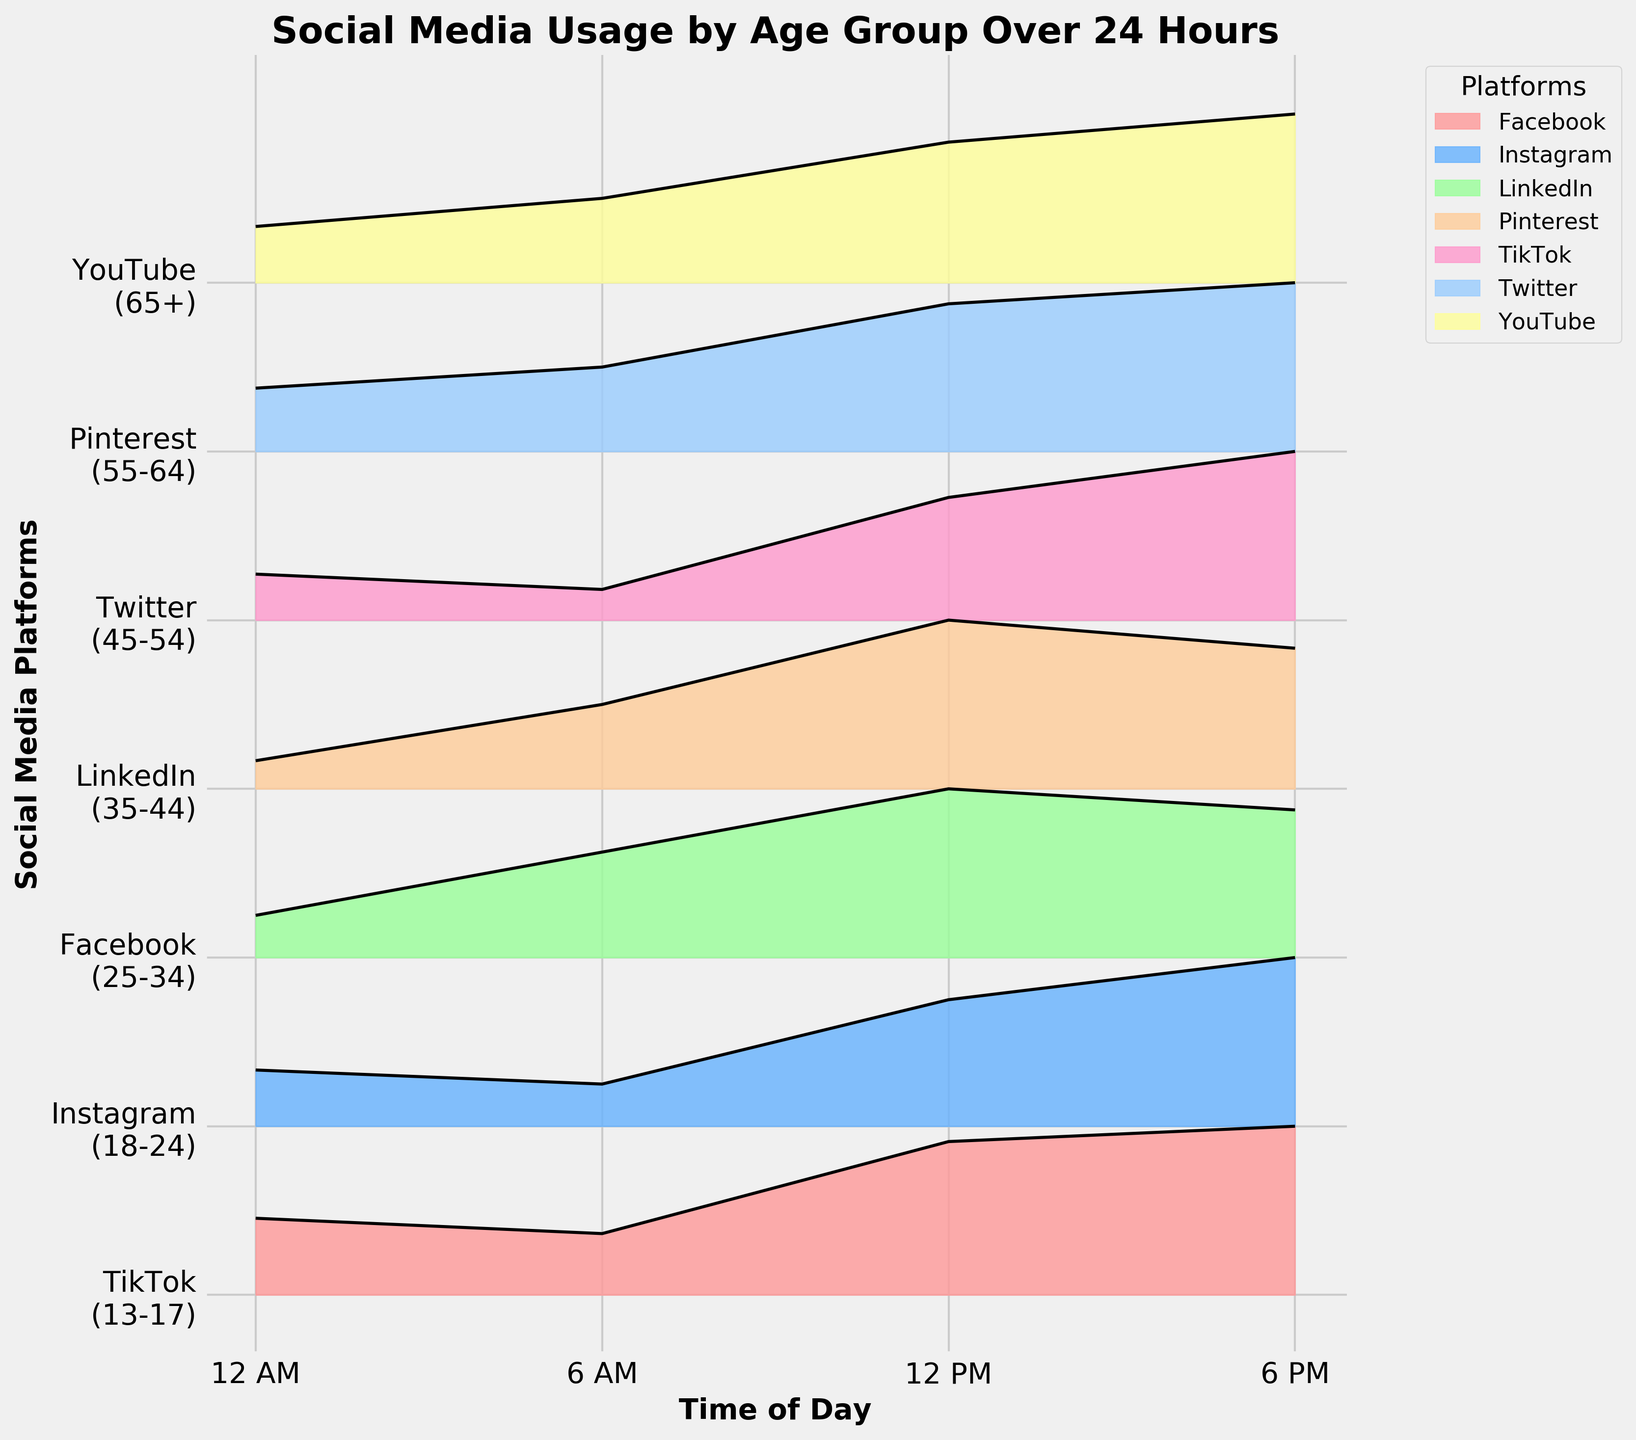What time does TikTok usage peak for age group 13-17? The ridgeline plot for TikTok shows the highest usage around 18 hours on the x-axis, indicating 6 PM.
Answer: 6 PM Which age group and platform have the highest usage at 12 PM? At 12 PM, the ridgeline plot shows the peak usage for the 18-24 age group on Instagram.
Answer: 18-24, Instagram Compare Facebook usage between 6 AM and 12 PM for the age group 25-34. Which time has higher usage? For the age group 25-34, the ridgeline plot for Facebook shows higher usage at 12 PM compared to 6 AM.
Answer: 12 PM Which platform has the lowest usage overall among all age groups? The ridgeline plot indicates that Pinterest for the 55-64 age group has the lowest peak usage value, which occurs at 12 PM. The maximum for Pinterest looks lower compared to other platforms.
Answer: Pinterest During which hours is Twitter usage higher than LinkedIn for their respective age groups? By examining the ridgeline plots, Twitter usage (45-54) exceeds LinkedIn usage (35-44) at 0 AM, 6 AM, and 12 PM.
Answer: 0 AM, 6 AM, 12 PM What is the difference in peak usage between Instagram (18-24) and Facebook (25-34) during their highest usage periods? The highest usage for Instagram (18-24) is 60 at 6 PM, and for Facebook (25-34), it is 55 at 12 PM. The difference is 60 - 55 = 5.
Answer: 5 Which platform shows the highest variance in usage over the 24-hour period? TikTok for the 13-17 age group shows noticeable peaks and troughs, indicating the highest variance in usage across the 24-hour period.
Answer: TikTok How does YouTube usage change from 6 AM to 6 PM for the 65+ age group? The ridgeline plot for YouTube shows an increase in usage from 15 at 6 AM to 30 at 6 PM for the 65+ age group.
Answer: Increases What is the combined usage of Pinterest across all highlighted hours? Pinterest for the 55-64 age group has usage values of 5 (12 AM) + 15 (6 AM) + 30 (12 PM) + 25 (6 PM) = 75.
Answer: 75 